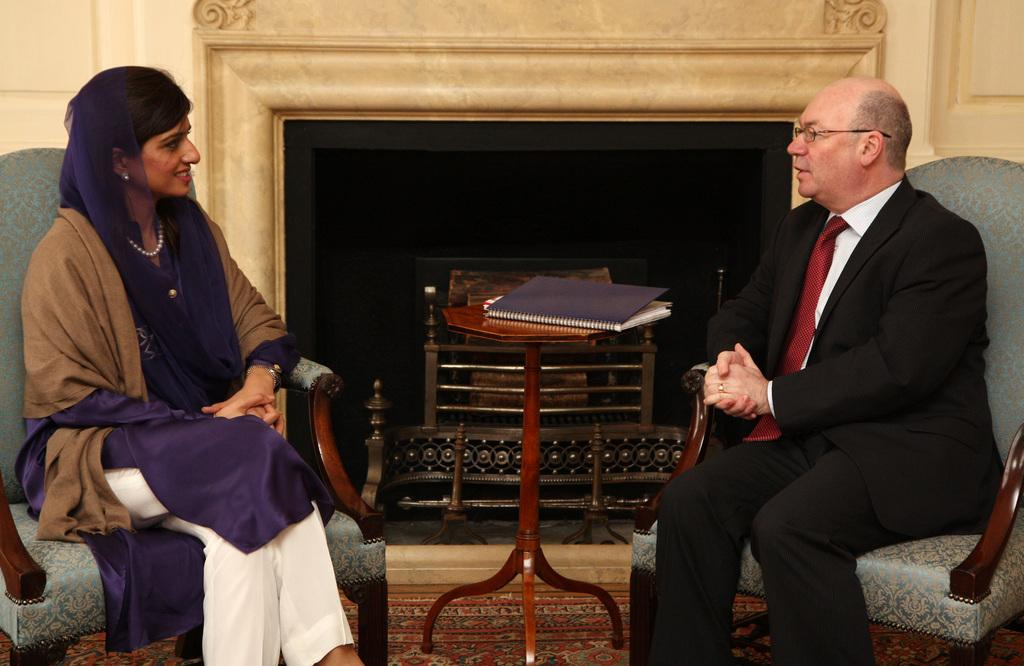Who is present in the image? There is a woman and a man in the image. What are the woman and man doing in the image? Both the woman and man are sitting in chairs. What object can be seen on a table in the image? There is a book on a table in the image. What feature is visible in the background of the image? There appears to be a fireplace in the background of the image. How does the earthquake affect the scale in the image? There is no earthquake or scale present in the image. 